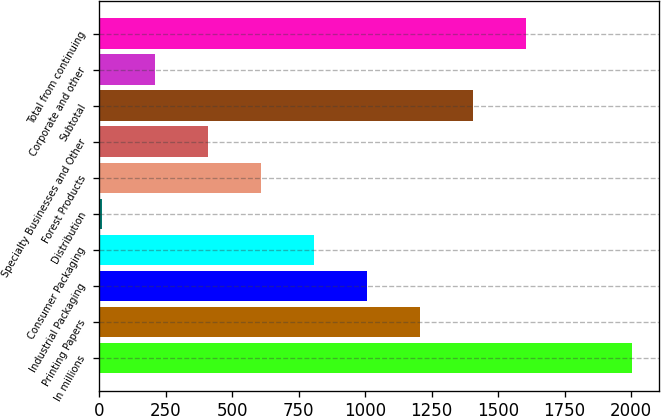Convert chart to OTSL. <chart><loc_0><loc_0><loc_500><loc_500><bar_chart><fcel>In millions<fcel>Printing Papers<fcel>Industrial Packaging<fcel>Consumer Packaging<fcel>Distribution<fcel>Forest Products<fcel>Specialty Businesses and Other<fcel>Subtotal<fcel>Corporate and other<fcel>Total from continuing<nl><fcel>2005<fcel>1206.6<fcel>1007<fcel>807.4<fcel>9<fcel>607.8<fcel>408.2<fcel>1406.2<fcel>208.6<fcel>1605.8<nl></chart> 